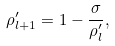Convert formula to latex. <formula><loc_0><loc_0><loc_500><loc_500>\rho ^ { \prime } _ { l + 1 } = 1 - { \frac { \sigma } { \rho ^ { \prime } _ { l } } } ,</formula> 